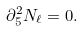Convert formula to latex. <formula><loc_0><loc_0><loc_500><loc_500>\partial _ { \bar { 5 } } ^ { 2 } N _ { \ell } = 0 .</formula> 